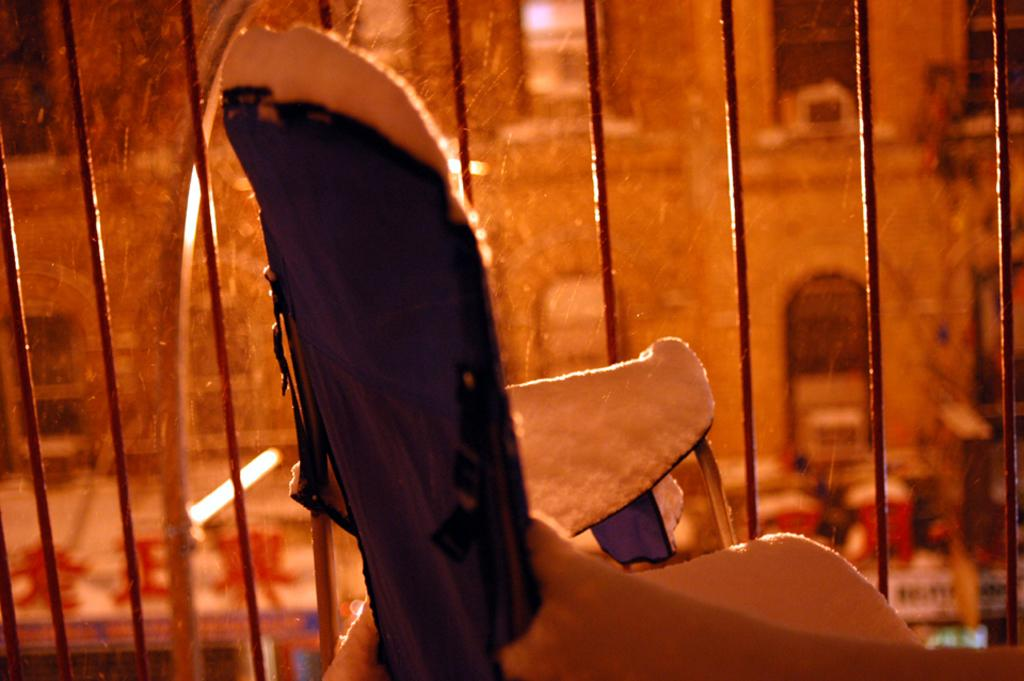What is the main object in the foreground of the image? There is a metal grill in the image. What can be seen in the background of the image? There is a building visible in the background of the image. Can you describe the cardboard object in the image? There appears to be a cardboard object in the image. What color is the cloth present in the image? A black cloth is present in the image. Where is the hill located in the image? There is no hill present in the image. What is the birth rate of the objects in the image? The birth rate of objects in the image is not applicable, as objects do not have a birth rate. 